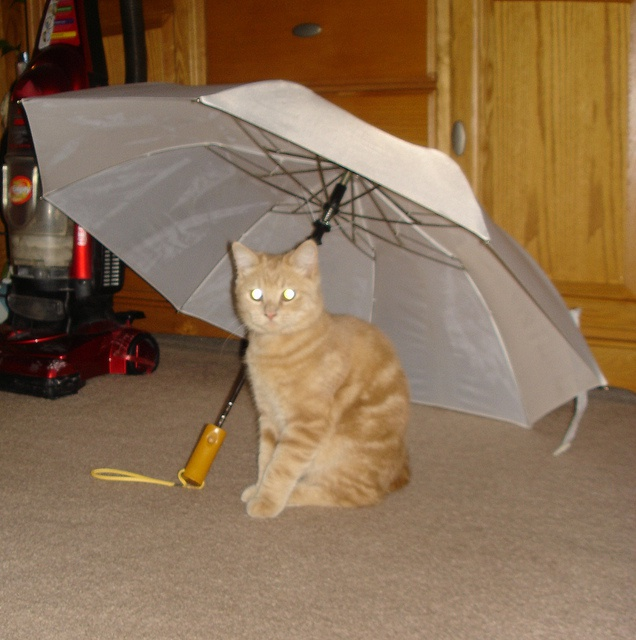Describe the objects in this image and their specific colors. I can see umbrella in maroon and gray tones and cat in maroon, tan, and gray tones in this image. 